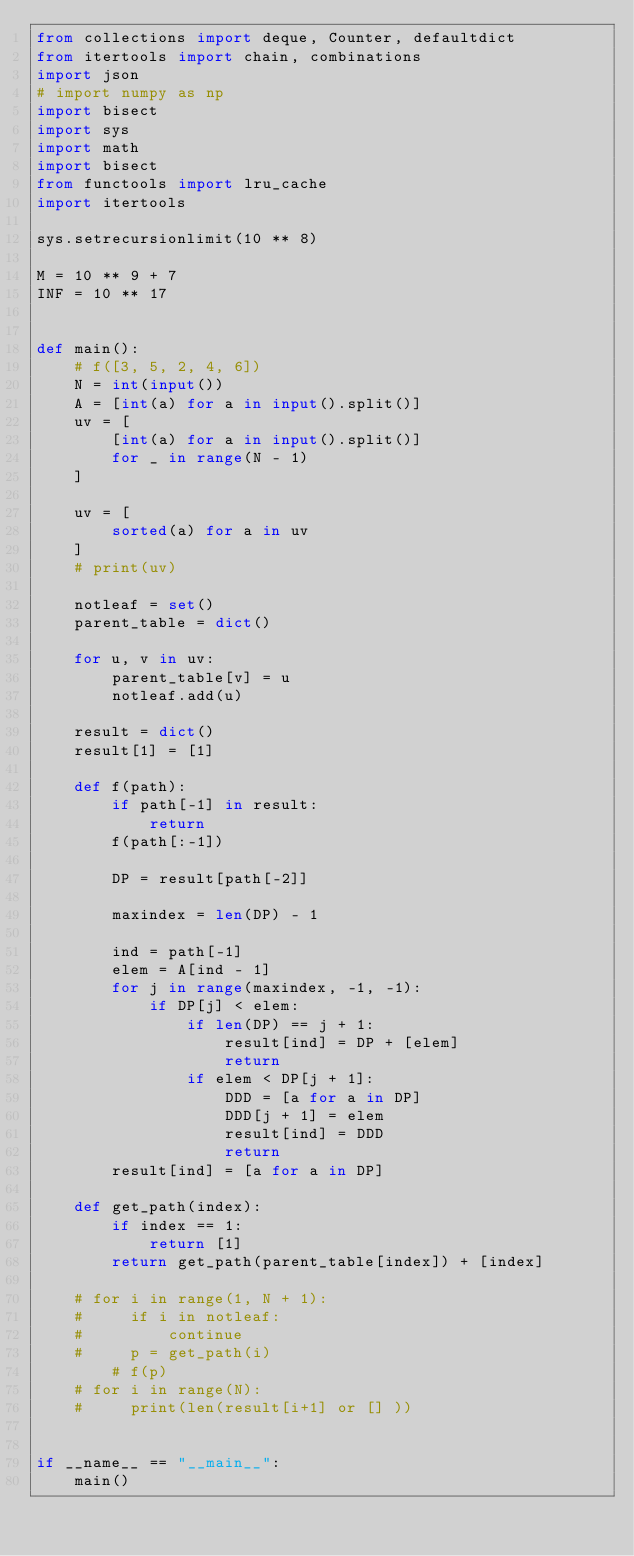Convert code to text. <code><loc_0><loc_0><loc_500><loc_500><_Python_>from collections import deque, Counter, defaultdict
from itertools import chain, combinations
import json
# import numpy as np
import bisect
import sys
import math
import bisect
from functools import lru_cache
import itertools

sys.setrecursionlimit(10 ** 8)

M = 10 ** 9 + 7
INF = 10 ** 17


def main():
    # f([3, 5, 2, 4, 6])
    N = int(input())
    A = [int(a) for a in input().split()]
    uv = [
        [int(a) for a in input().split()]
        for _ in range(N - 1)
    ]

    uv = [
        sorted(a) for a in uv
    ]
    # print(uv)

    notleaf = set()
    parent_table = dict()

    for u, v in uv:
        parent_table[v] = u
        notleaf.add(u)

    result = dict()
    result[1] = [1]

    def f(path):
        if path[-1] in result:
            return
        f(path[:-1])

        DP = result[path[-2]]

        maxindex = len(DP) - 1

        ind = path[-1]
        elem = A[ind - 1]
        for j in range(maxindex, -1, -1):
            if DP[j] < elem:
                if len(DP) == j + 1:
                    result[ind] = DP + [elem]
                    return
                if elem < DP[j + 1]:
                    DDD = [a for a in DP]
                    DDD[j + 1] = elem
                    result[ind] = DDD
                    return
        result[ind] = [a for a in DP]

    def get_path(index):
        if index == 1:
            return [1]
        return get_path(parent_table[index]) + [index]

    # for i in range(1, N + 1):
    #     if i in notleaf:
    #         continue
    #     p = get_path(i)
        # f(p)
    # for i in range(N):
    #     print(len(result[i+1] or [] ))


if __name__ == "__main__":
    main()
</code> 